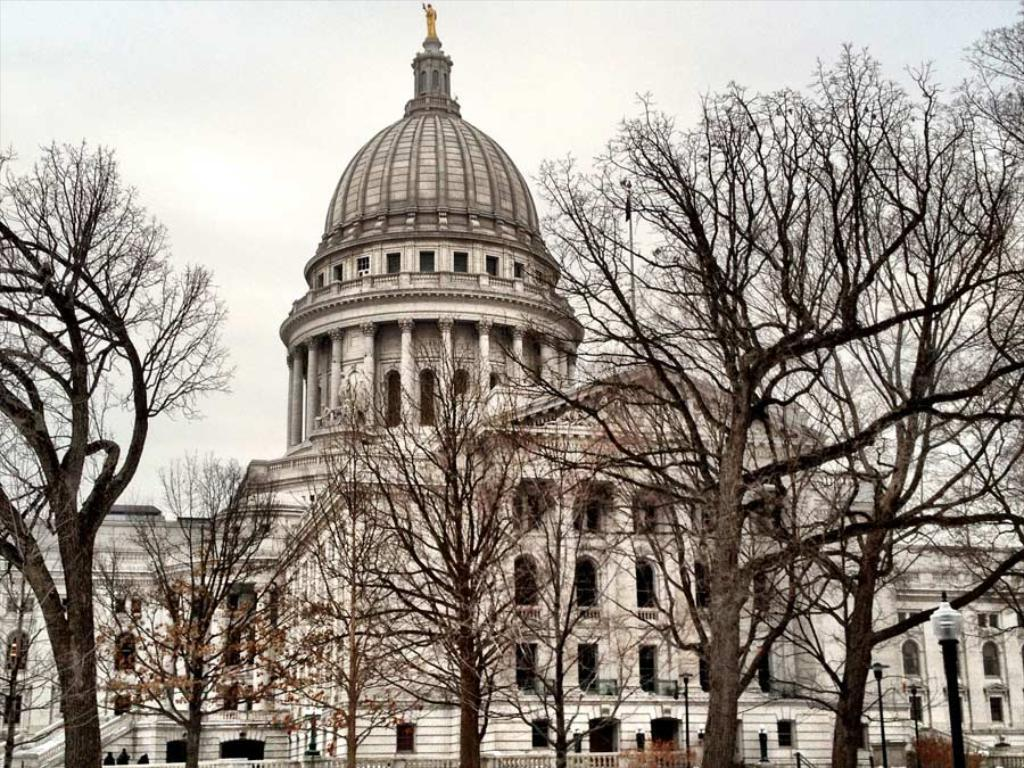What is the main structure in the image? There is a castle in the image. What features can be seen on the castle? The castle has windows and pillars. Is there any other significant object within the castle? Yes, there is a statue in the center of the castle. What is visible in front of the castle? There are trees before the castle. What is visible at the top of the image? The sky is visible at the top of the image. What type of popcorn is being served in the jar next to the castle? There is no popcorn or jar present in the image; it features a castle with windows, pillars, a statue, trees, and a visible sky. 